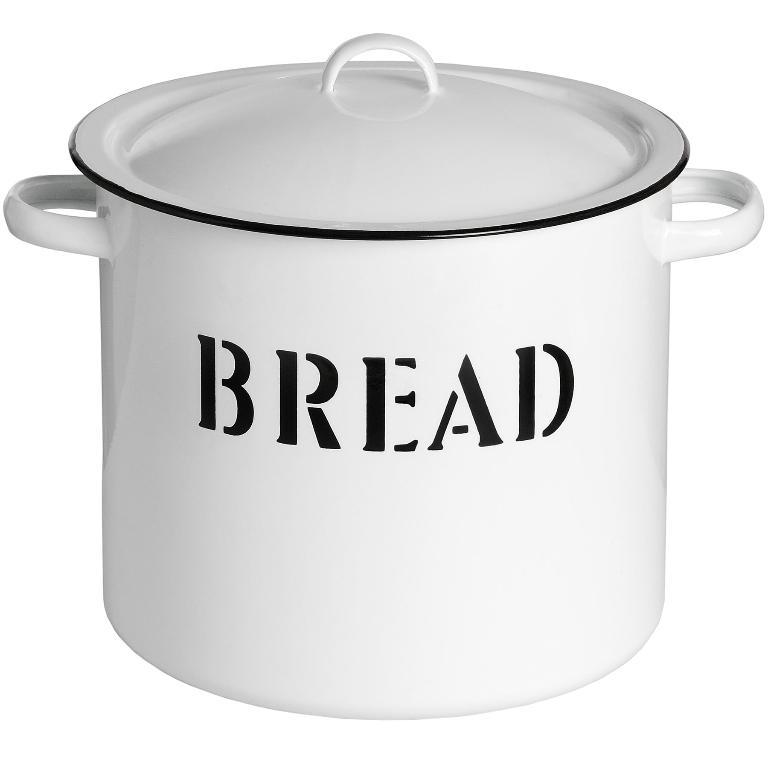What is written on those banners?
Give a very brief answer. Unanswerable. 